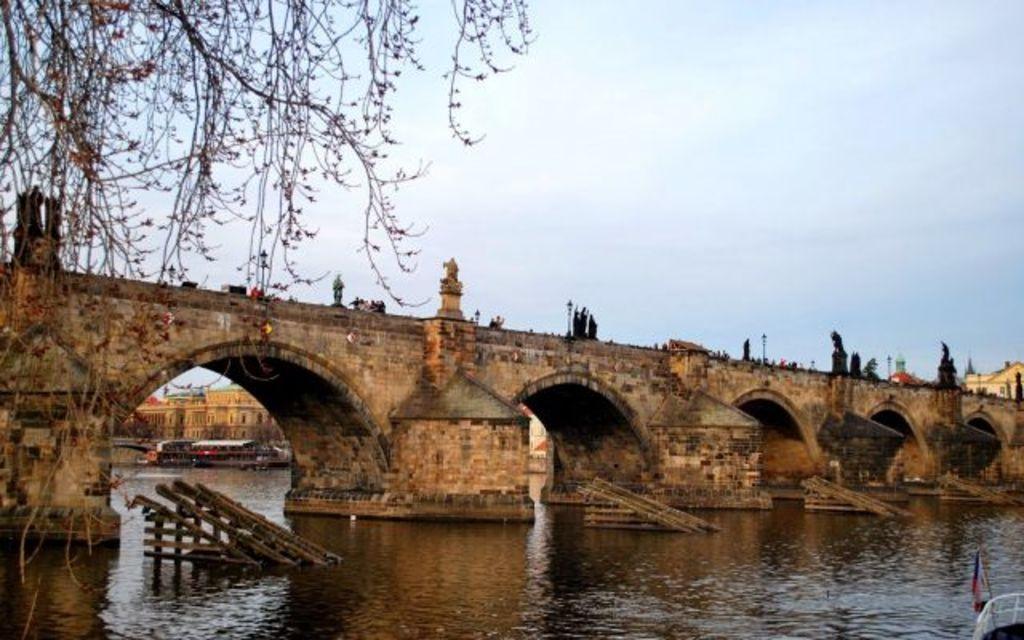How would you summarize this image in a sentence or two? In the center we can see the sky, buildings, branches, one bridge with pillars and arches, water, poles and a few other objects. At the bottom right side of the image, there is a fence and a flag. 